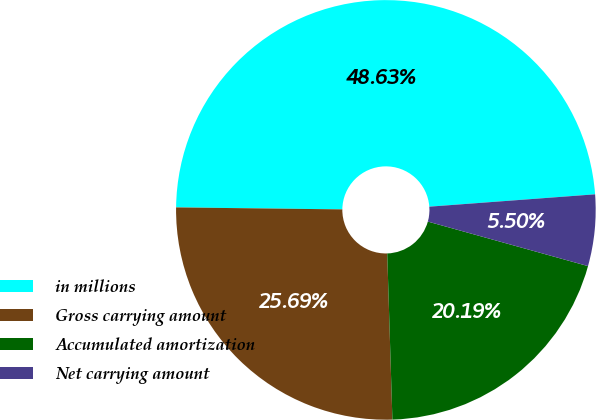Convert chart to OTSL. <chart><loc_0><loc_0><loc_500><loc_500><pie_chart><fcel>in millions<fcel>Gross carrying amount<fcel>Accumulated amortization<fcel>Net carrying amount<nl><fcel>48.63%<fcel>25.69%<fcel>20.19%<fcel>5.5%<nl></chart> 